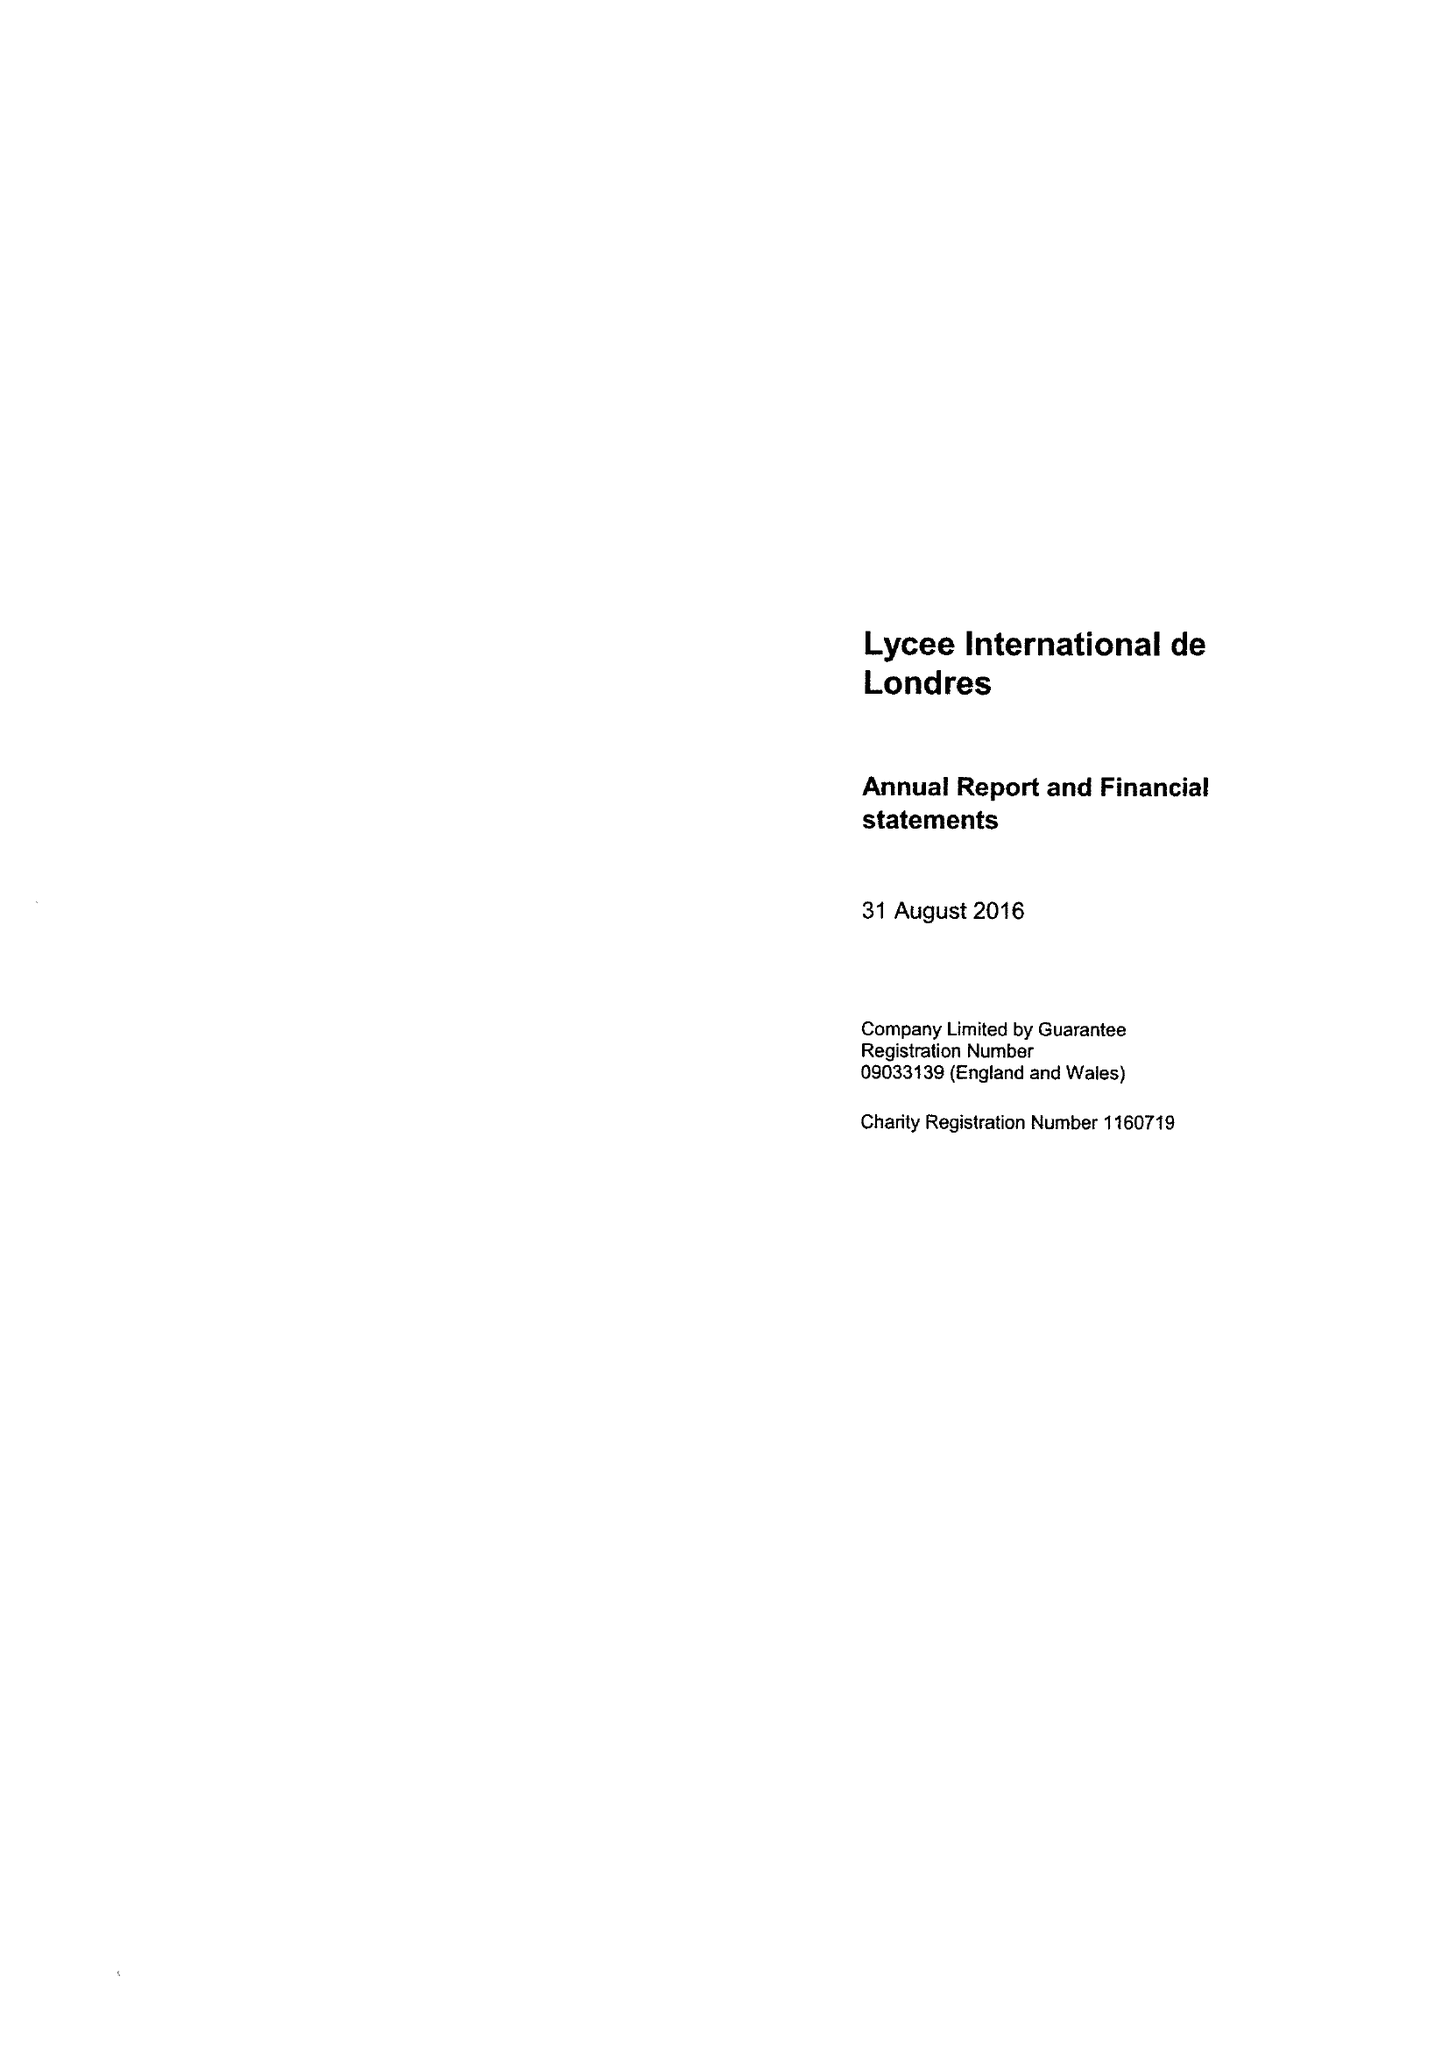What is the value for the report_date?
Answer the question using a single word or phrase. 2016-08-31 